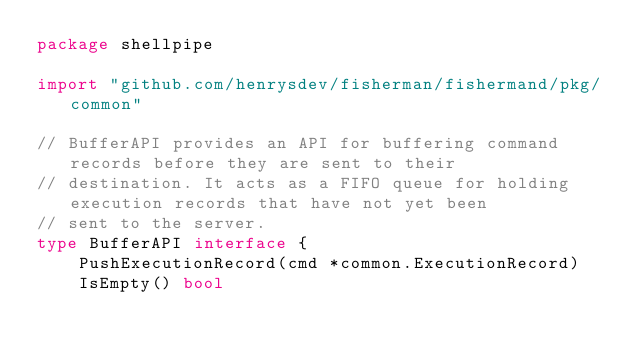Convert code to text. <code><loc_0><loc_0><loc_500><loc_500><_Go_>package shellpipe

import "github.com/henrysdev/fisherman/fishermand/pkg/common"

// BufferAPI provides an API for buffering command records before they are sent to their
// destination. It acts as a FIFO queue for holding execution records that have not yet been
// sent to the server.
type BufferAPI interface {
	PushExecutionRecord(cmd *common.ExecutionRecord)
	IsEmpty() bool</code> 